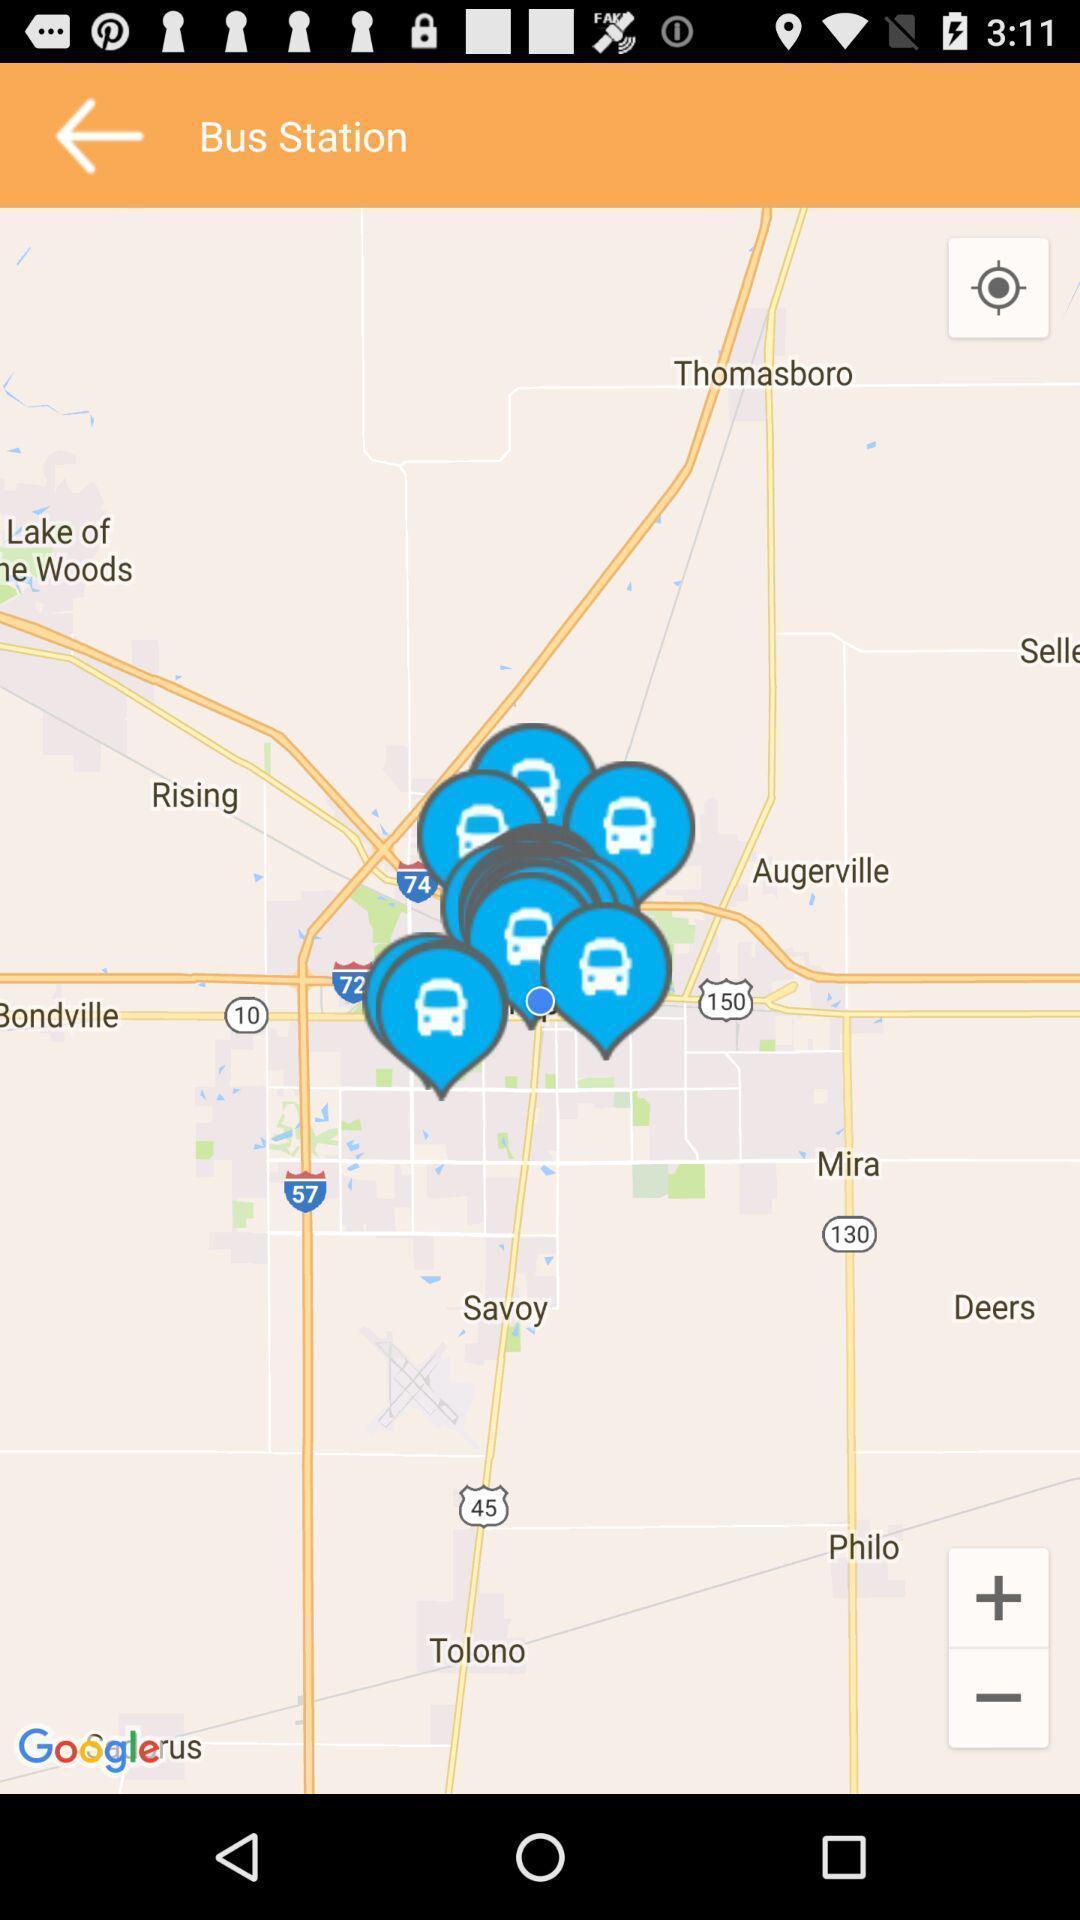Give me a narrative description of this picture. Screen displaying a route map for bus station. 